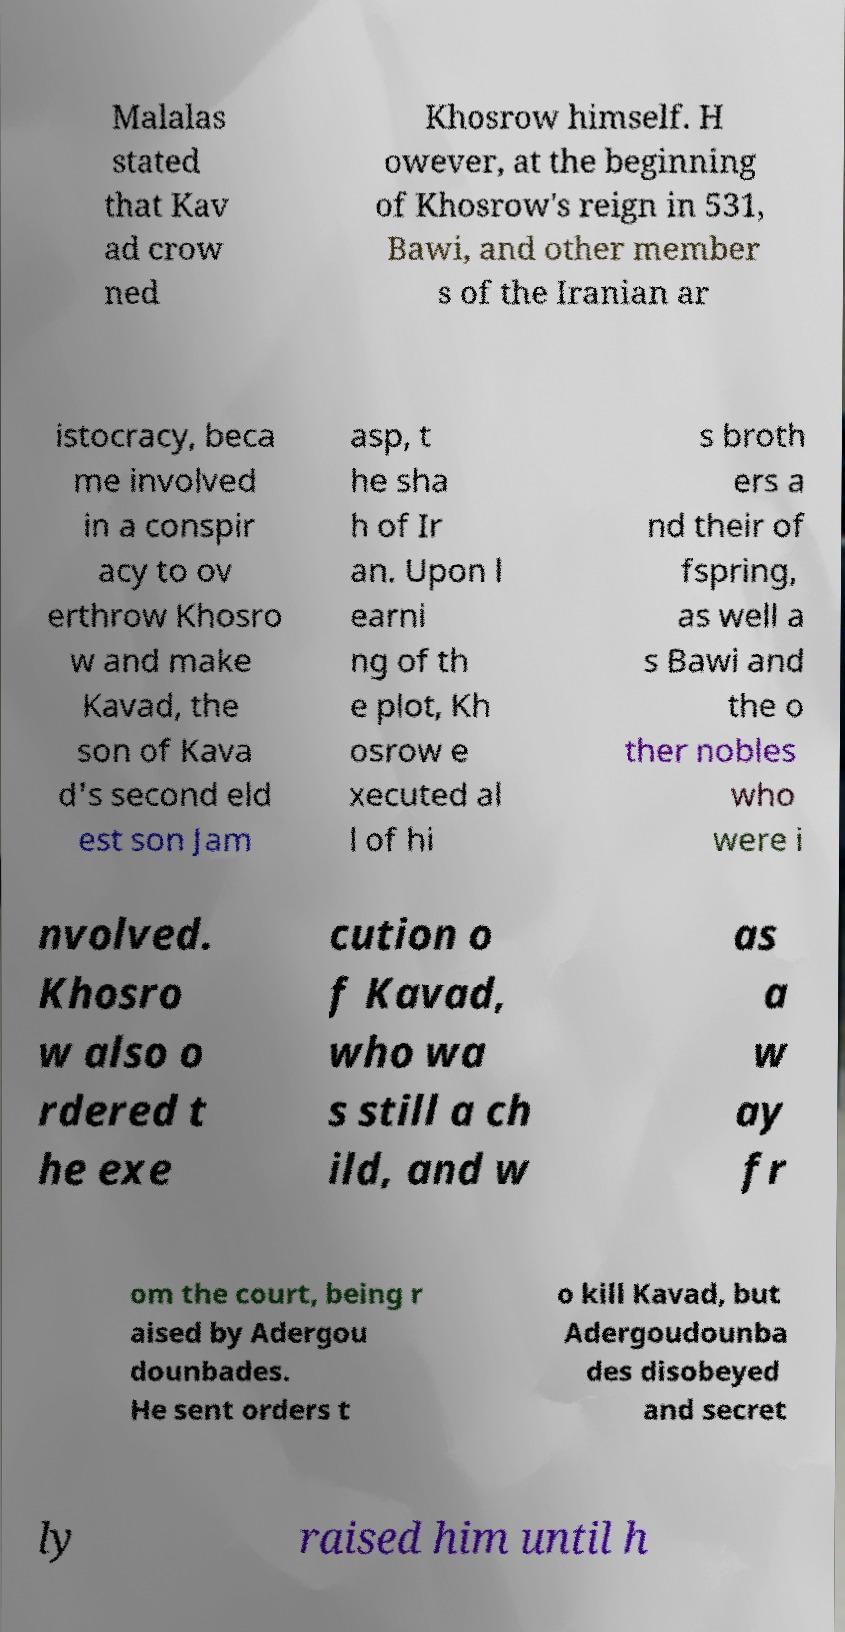Can you read and provide the text displayed in the image?This photo seems to have some interesting text. Can you extract and type it out for me? Malalas stated that Kav ad crow ned Khosrow himself. H owever, at the beginning of Khosrow's reign in 531, Bawi, and other member s of the Iranian ar istocracy, beca me involved in a conspir acy to ov erthrow Khosro w and make Kavad, the son of Kava d's second eld est son Jam asp, t he sha h of Ir an. Upon l earni ng of th e plot, Kh osrow e xecuted al l of hi s broth ers a nd their of fspring, as well a s Bawi and the o ther nobles who were i nvolved. Khosro w also o rdered t he exe cution o f Kavad, who wa s still a ch ild, and w as a w ay fr om the court, being r aised by Adergou dounbades. He sent orders t o kill Kavad, but Adergoudounba des disobeyed and secret ly raised him until h 